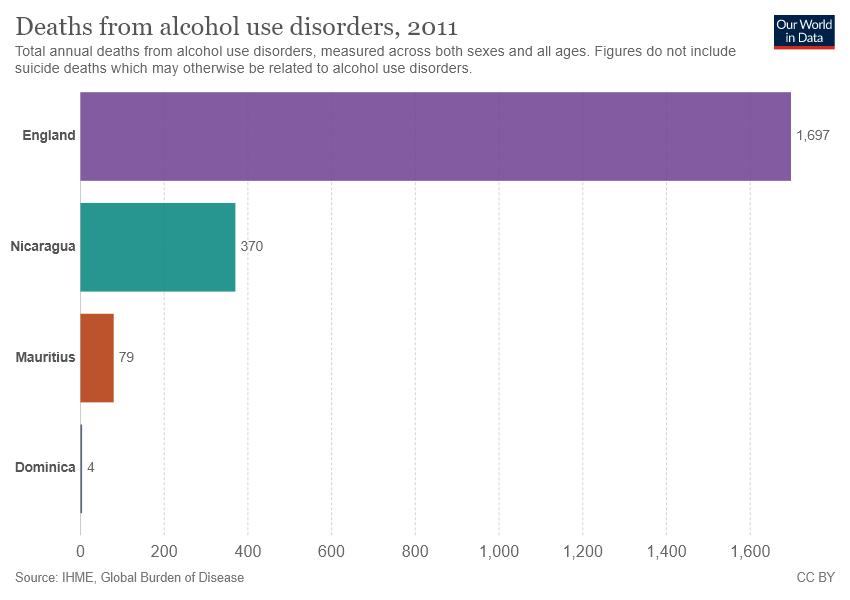Point out several critical features in this image. The color purple represents England in the chart. The sum value of Mauritius and Dominica is 83. 